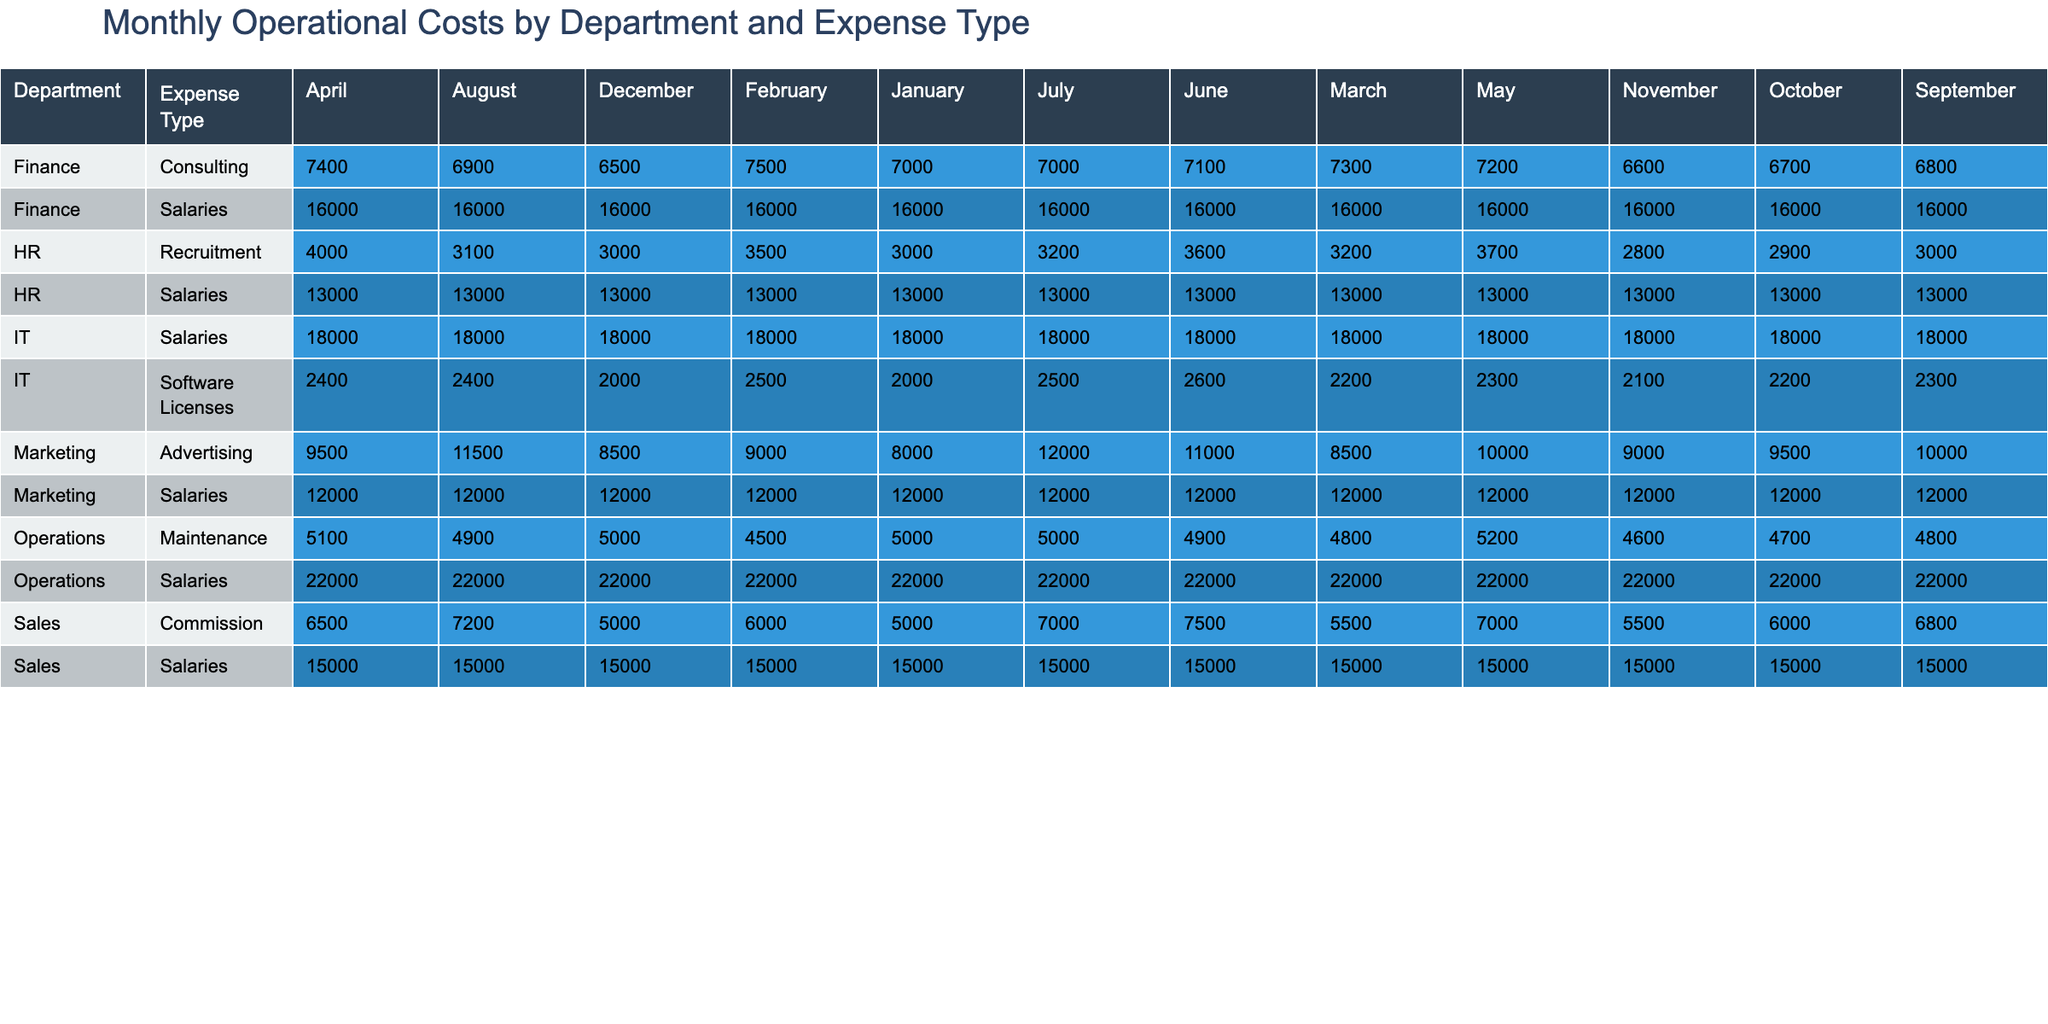What are the total salaries paid in the Marketing department for the year? The total salaries in the Marketing department are found by summing the monthly salaries for each month: 12000 (January) + 12000 (February) + 12000 (March) + 12000 (April) + 12000 (May) + 12000 (June) + 12000 (July) + 12000 (August) + 12000 (September) + 12000 (October) + 12000 (November) + 12000 (December) = 144000.
Answer: 144000 Did the Finance department incur any consulting costs in any month? By checking all the months for the Finance department's consulting costs, it is clear that there are values present from January to December, indicating that the Finance department did incur consulting costs.
Answer: Yes What is the average commission amount paid in the Sales department over the year? The commission amounts for the Sales department are: 5000, 6000, 5500, 6500, 7000, 7500, 7000, 7200, 6800, 6000, 5500, 5000. Sum them up: 5000 + 6000 + 5500 + 6500 + 7000 + 7500 + 7000 + 7200 + 6800 + 6000 + 5500 + 5000 = 71500. This sum is divided by 12 (the number of months) to get the average: 71500 / 12 = 5958.33.
Answer: 5958.33 Which department had the highest operational costs in May? By reviewing the operational costs for each department in May, we find: Marketing (12000 + 10000 = 22000), Sales (15000 + 7000 = 22000), IT (18000 + 2300 = 20300), HR (13000 + 3700 = 16700), Operations (22000 + 5200 = 27200), Finance (16000 + 7200 = 23200). The total for Operations is the highest at 27200.
Answer: Operations What was the total maintenance cost for the Operations department across the year, and how does it compare to the HR recruitment costs? To calculate the total maintenance costs for Operations: 5000 + 4500 + 4800 + 5100 + 5200 + 4900 + 5000 + 4900 + 4800 + 4700 + 4600 + 5000 = 59100. For HR recruitment costs, we find: 3000 + 3500 + 3200 + 4000 + 3700 + 3600 + 3200 + 3100 + 3000 + 2900 + 2800 + 3000 = 39500. Comparing both totals: 59100 > 39500, indicating maintenance costs far exceed recruitment costs.
Answer: 59100 (higher than 39500) 